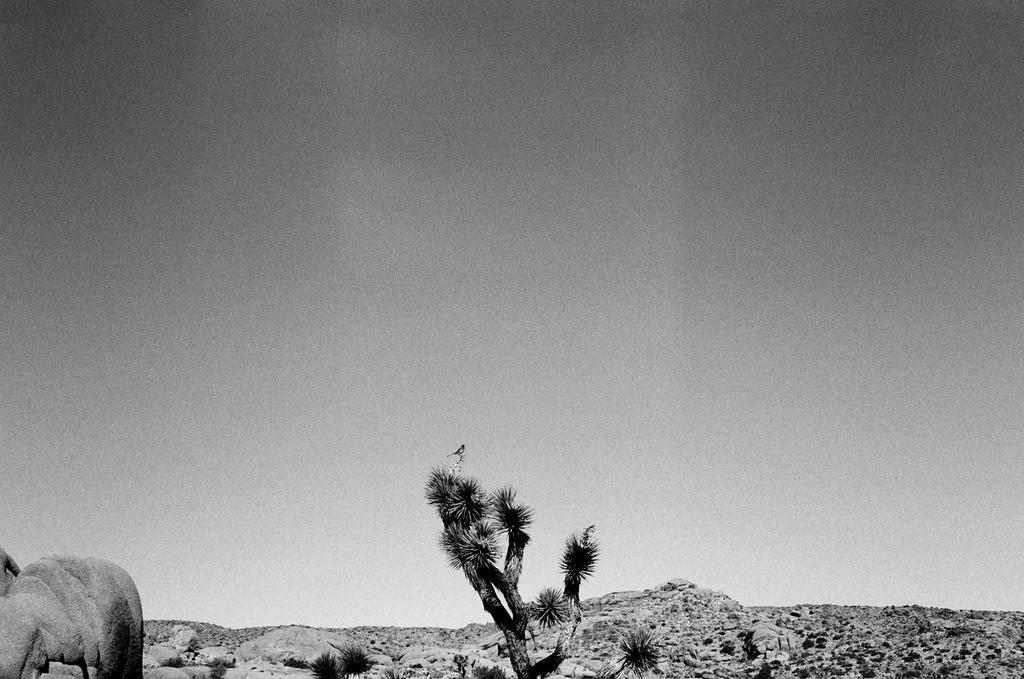Could you give a brief overview of what you see in this image? In the image we can see the black and white picture of the tree, stones, sky and the bird. 